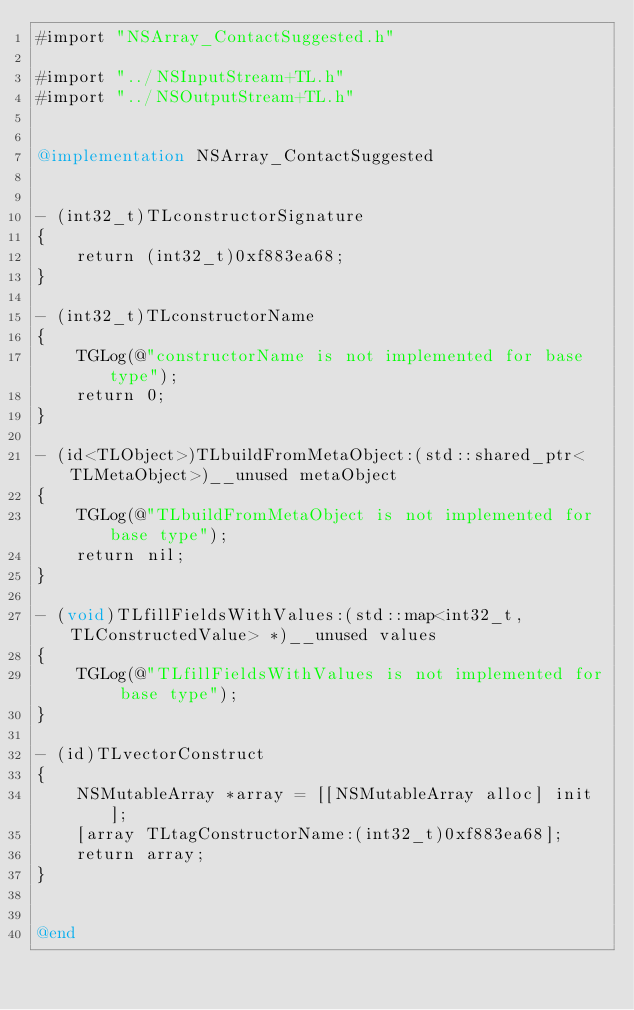<code> <loc_0><loc_0><loc_500><loc_500><_ObjectiveC_>#import "NSArray_ContactSuggested.h"

#import "../NSInputStream+TL.h"
#import "../NSOutputStream+TL.h"


@implementation NSArray_ContactSuggested


- (int32_t)TLconstructorSignature
{
    return (int32_t)0xf883ea68;
}

- (int32_t)TLconstructorName
{
    TGLog(@"constructorName is not implemented for base type");
    return 0;
}

- (id<TLObject>)TLbuildFromMetaObject:(std::shared_ptr<TLMetaObject>)__unused metaObject
{
    TGLog(@"TLbuildFromMetaObject is not implemented for base type");
    return nil;
}

- (void)TLfillFieldsWithValues:(std::map<int32_t, TLConstructedValue> *)__unused values
{
    TGLog(@"TLfillFieldsWithValues is not implemented for base type");
}

- (id)TLvectorConstruct
{
    NSMutableArray *array = [[NSMutableArray alloc] init];
    [array TLtagConstructorName:(int32_t)0xf883ea68];
    return array;
}


@end

</code> 